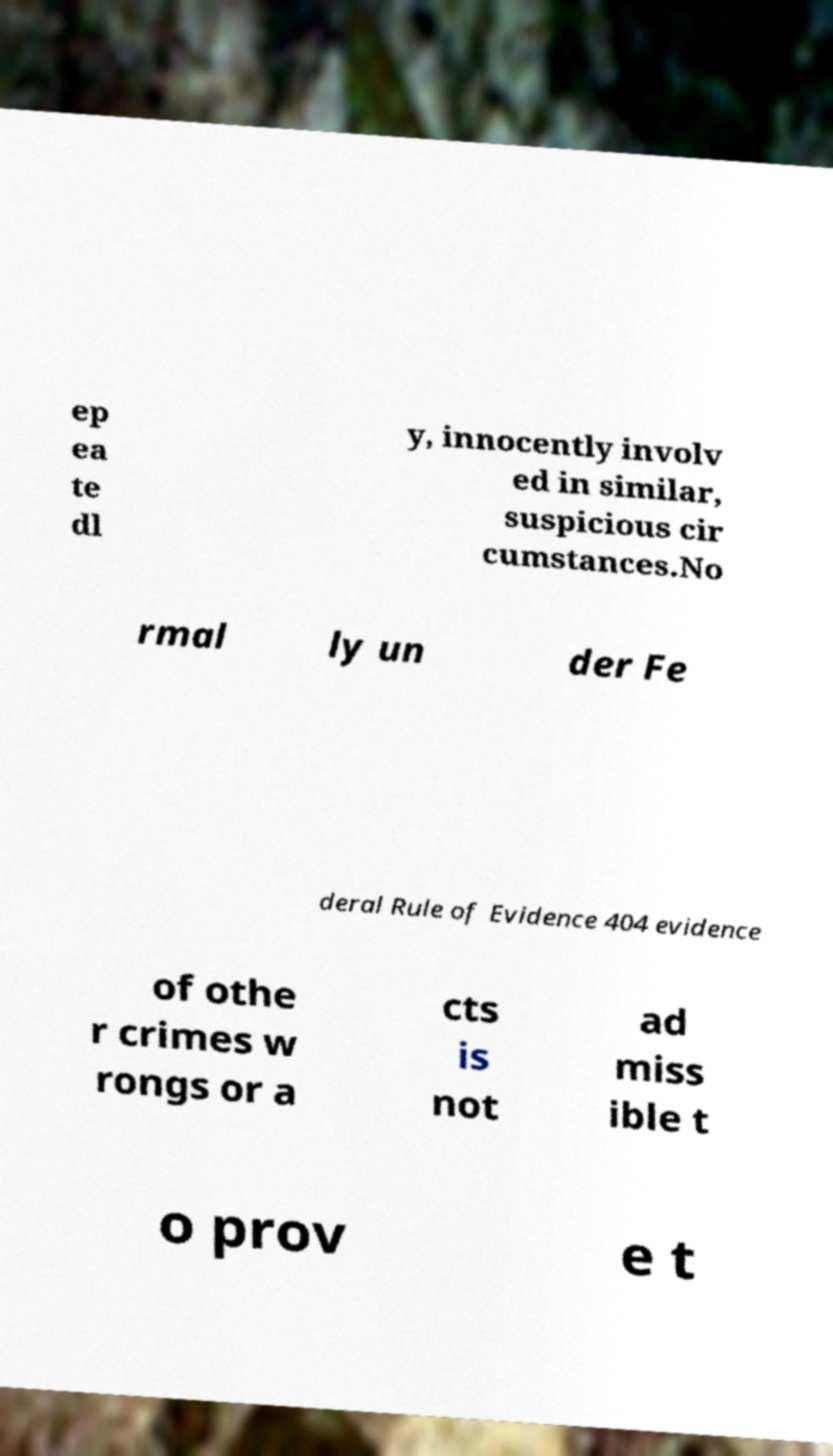Please read and relay the text visible in this image. What does it say? ep ea te dl y, innocently involv ed in similar, suspicious cir cumstances.No rmal ly un der Fe deral Rule of Evidence 404 evidence of othe r crimes w rongs or a cts is not ad miss ible t o prov e t 